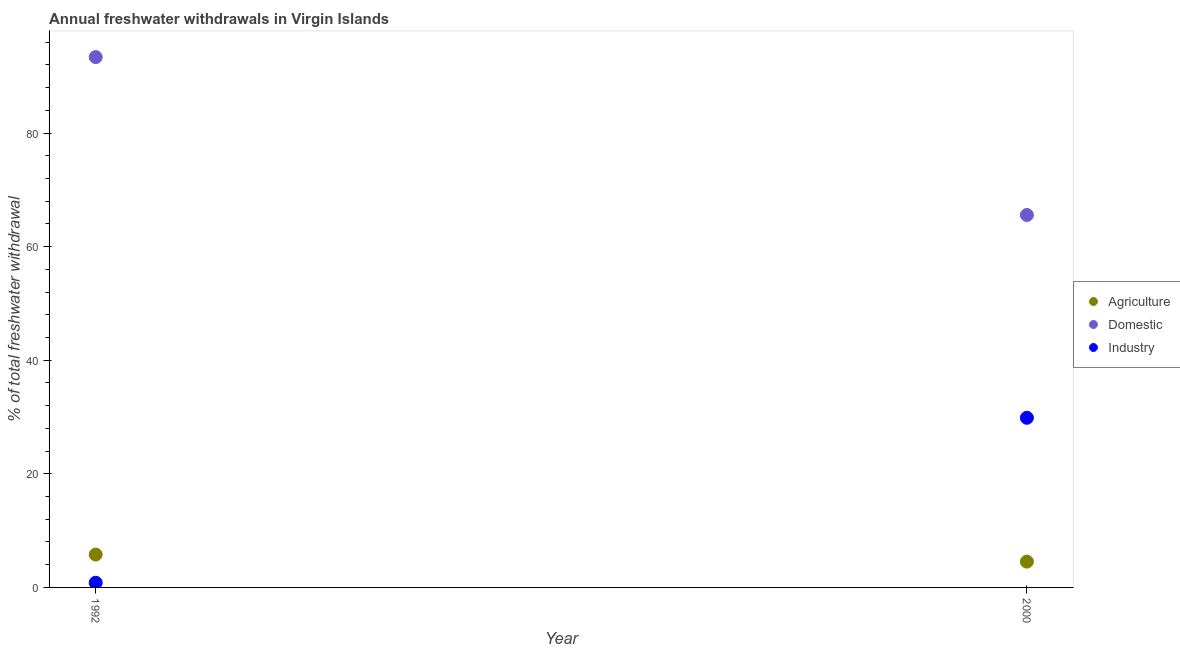Is the number of dotlines equal to the number of legend labels?
Your answer should be compact. Yes. What is the percentage of freshwater withdrawal for industry in 1992?
Offer a very short reply. 0.83. Across all years, what is the maximum percentage of freshwater withdrawal for agriculture?
Ensure brevity in your answer.  5.79. Across all years, what is the minimum percentage of freshwater withdrawal for agriculture?
Offer a terse response. 4.54. In which year was the percentage of freshwater withdrawal for domestic purposes maximum?
Your response must be concise. 1992. In which year was the percentage of freshwater withdrawal for industry minimum?
Your answer should be very brief. 1992. What is the total percentage of freshwater withdrawal for domestic purposes in the graph?
Ensure brevity in your answer.  158.96. What is the difference between the percentage of freshwater withdrawal for domestic purposes in 1992 and that in 2000?
Offer a terse response. 27.8. What is the difference between the percentage of freshwater withdrawal for industry in 2000 and the percentage of freshwater withdrawal for agriculture in 1992?
Your answer should be very brief. 24.09. What is the average percentage of freshwater withdrawal for domestic purposes per year?
Make the answer very short. 79.48. In the year 2000, what is the difference between the percentage of freshwater withdrawal for domestic purposes and percentage of freshwater withdrawal for agriculture?
Keep it short and to the point. 61.03. In how many years, is the percentage of freshwater withdrawal for domestic purposes greater than 84 %?
Offer a very short reply. 1. What is the ratio of the percentage of freshwater withdrawal for domestic purposes in 1992 to that in 2000?
Your response must be concise. 1.42. In how many years, is the percentage of freshwater withdrawal for domestic purposes greater than the average percentage of freshwater withdrawal for domestic purposes taken over all years?
Keep it short and to the point. 1. Is the percentage of freshwater withdrawal for domestic purposes strictly greater than the percentage of freshwater withdrawal for industry over the years?
Your response must be concise. Yes. Is the percentage of freshwater withdrawal for domestic purposes strictly less than the percentage of freshwater withdrawal for agriculture over the years?
Ensure brevity in your answer.  No. What is the difference between two consecutive major ticks on the Y-axis?
Give a very brief answer. 20. Does the graph contain any zero values?
Make the answer very short. No. How many legend labels are there?
Your response must be concise. 3. What is the title of the graph?
Keep it short and to the point. Annual freshwater withdrawals in Virgin Islands. Does "Maunufacturing" appear as one of the legend labels in the graph?
Your answer should be compact. No. What is the label or title of the Y-axis?
Offer a very short reply. % of total freshwater withdrawal. What is the % of total freshwater withdrawal in Agriculture in 1992?
Provide a succinct answer. 5.79. What is the % of total freshwater withdrawal in Domestic in 1992?
Your answer should be very brief. 93.38. What is the % of total freshwater withdrawal of Industry in 1992?
Keep it short and to the point. 0.83. What is the % of total freshwater withdrawal of Agriculture in 2000?
Provide a short and direct response. 4.54. What is the % of total freshwater withdrawal of Domestic in 2000?
Your answer should be compact. 65.58. What is the % of total freshwater withdrawal in Industry in 2000?
Give a very brief answer. 29.87. Across all years, what is the maximum % of total freshwater withdrawal of Agriculture?
Keep it short and to the point. 5.79. Across all years, what is the maximum % of total freshwater withdrawal of Domestic?
Make the answer very short. 93.38. Across all years, what is the maximum % of total freshwater withdrawal in Industry?
Offer a terse response. 29.87. Across all years, what is the minimum % of total freshwater withdrawal in Agriculture?
Your response must be concise. 4.54. Across all years, what is the minimum % of total freshwater withdrawal in Domestic?
Offer a terse response. 65.58. Across all years, what is the minimum % of total freshwater withdrawal in Industry?
Make the answer very short. 0.83. What is the total % of total freshwater withdrawal of Agriculture in the graph?
Offer a terse response. 10.33. What is the total % of total freshwater withdrawal of Domestic in the graph?
Offer a very short reply. 158.96. What is the total % of total freshwater withdrawal in Industry in the graph?
Your answer should be compact. 30.7. What is the difference between the % of total freshwater withdrawal of Agriculture in 1992 and that in 2000?
Your answer should be compact. 1.24. What is the difference between the % of total freshwater withdrawal of Domestic in 1992 and that in 2000?
Provide a succinct answer. 27.8. What is the difference between the % of total freshwater withdrawal of Industry in 1992 and that in 2000?
Offer a very short reply. -29.04. What is the difference between the % of total freshwater withdrawal in Agriculture in 1992 and the % of total freshwater withdrawal in Domestic in 2000?
Keep it short and to the point. -59.8. What is the difference between the % of total freshwater withdrawal of Agriculture in 1992 and the % of total freshwater withdrawal of Industry in 2000?
Keep it short and to the point. -24.09. What is the difference between the % of total freshwater withdrawal of Domestic in 1992 and the % of total freshwater withdrawal of Industry in 2000?
Provide a succinct answer. 63.51. What is the average % of total freshwater withdrawal in Agriculture per year?
Your response must be concise. 5.17. What is the average % of total freshwater withdrawal in Domestic per year?
Offer a terse response. 79.48. What is the average % of total freshwater withdrawal of Industry per year?
Give a very brief answer. 15.35. In the year 1992, what is the difference between the % of total freshwater withdrawal in Agriculture and % of total freshwater withdrawal in Domestic?
Keep it short and to the point. -87.59. In the year 1992, what is the difference between the % of total freshwater withdrawal in Agriculture and % of total freshwater withdrawal in Industry?
Your answer should be very brief. 4.96. In the year 1992, what is the difference between the % of total freshwater withdrawal of Domestic and % of total freshwater withdrawal of Industry?
Keep it short and to the point. 92.55. In the year 2000, what is the difference between the % of total freshwater withdrawal of Agriculture and % of total freshwater withdrawal of Domestic?
Keep it short and to the point. -61.03. In the year 2000, what is the difference between the % of total freshwater withdrawal in Agriculture and % of total freshwater withdrawal in Industry?
Your answer should be very brief. -25.32. In the year 2000, what is the difference between the % of total freshwater withdrawal of Domestic and % of total freshwater withdrawal of Industry?
Provide a short and direct response. 35.71. What is the ratio of the % of total freshwater withdrawal of Agriculture in 1992 to that in 2000?
Your answer should be very brief. 1.27. What is the ratio of the % of total freshwater withdrawal of Domestic in 1992 to that in 2000?
Offer a terse response. 1.42. What is the ratio of the % of total freshwater withdrawal in Industry in 1992 to that in 2000?
Ensure brevity in your answer.  0.03. What is the difference between the highest and the second highest % of total freshwater withdrawal of Agriculture?
Your answer should be very brief. 1.24. What is the difference between the highest and the second highest % of total freshwater withdrawal in Domestic?
Keep it short and to the point. 27.8. What is the difference between the highest and the second highest % of total freshwater withdrawal of Industry?
Your response must be concise. 29.04. What is the difference between the highest and the lowest % of total freshwater withdrawal of Agriculture?
Your response must be concise. 1.24. What is the difference between the highest and the lowest % of total freshwater withdrawal in Domestic?
Your answer should be compact. 27.8. What is the difference between the highest and the lowest % of total freshwater withdrawal in Industry?
Provide a succinct answer. 29.04. 